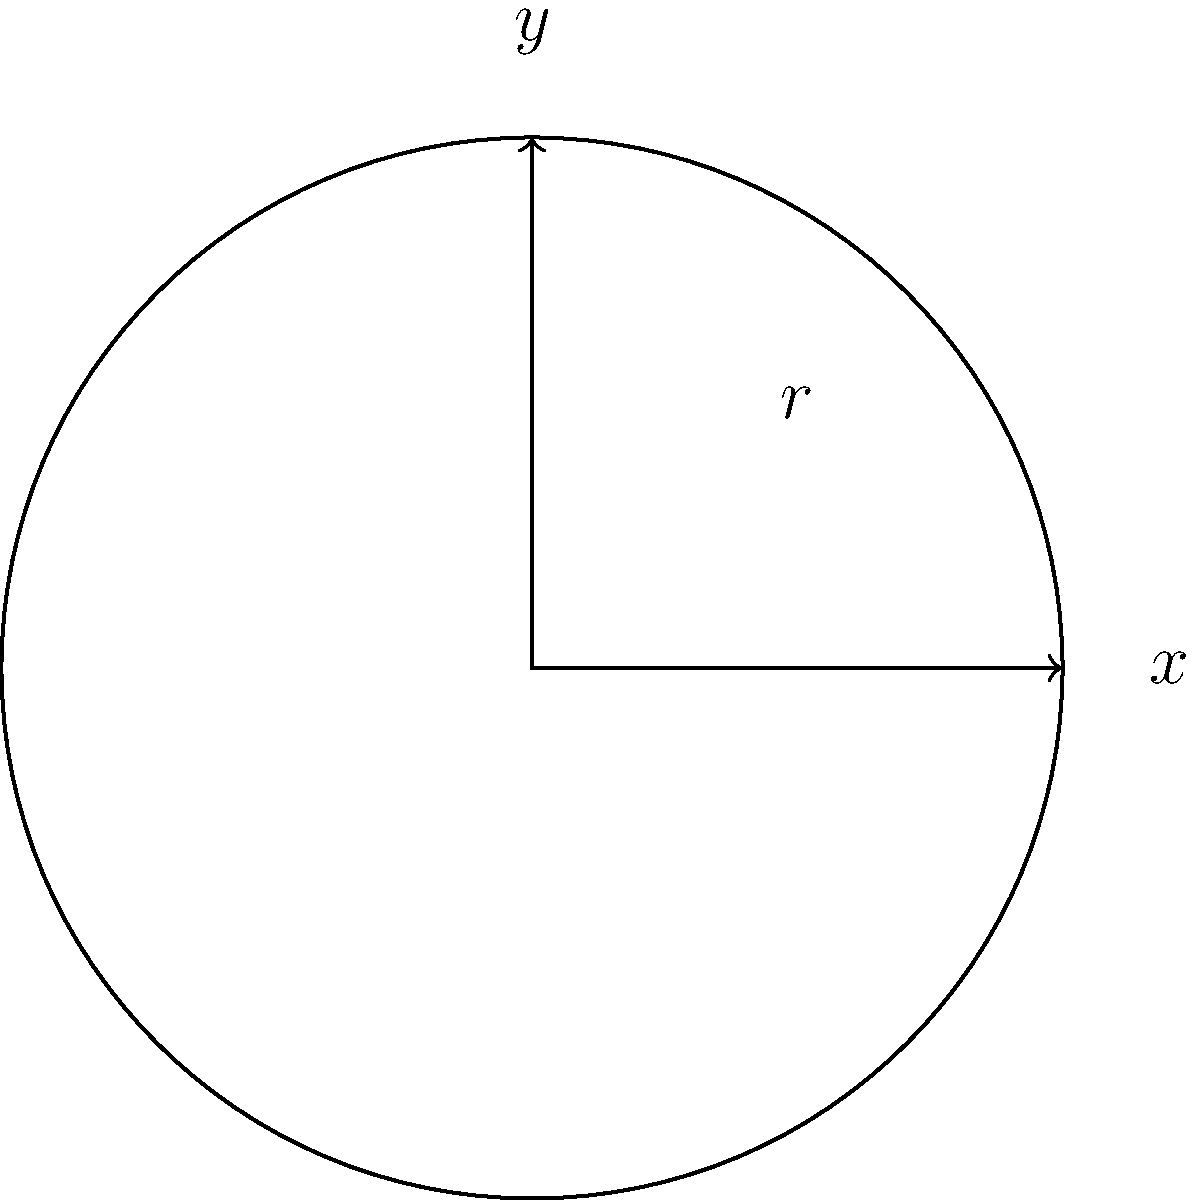As a sports equipment store owner, you're skeptical about new-fangled measuring devices. Using traditional calculus methods, determine the volume of a regulation basketball with a radius of 4.7 inches. Round your answer to the nearest cubic inch. To find the volume of a sphere using calculus, we'll use the method of cylindrical shells:

1) The volume of a sphere is given by the formula:
   $$V = 2\pi \int_0^r y(r^2 - y^2)dy$$
   where $r$ is the radius of the sphere.

2) In this case, $r = 4.7$ inches.

3) Let's substitute this into our formula:
   $$V = 2\pi \int_0^{4.7} y(4.7^2 - y^2)dy$$

4) Simplify the integrand:
   $$V = 2\pi \int_0^{4.7} (22.09y - y^3)dy$$

5) Integrate:
   $$V = 2\pi \left[\frac{22.09y^2}{2} - \frac{y^4}{4}\right]_0^{4.7}$$

6) Evaluate the integral:
   $$V = 2\pi \left(\frac{22.09(4.7)^2}{2} - \frac{(4.7)^4}{4} - 0\right)$$

7) Calculate:
   $$V = 2\pi(243.4423 - 121.7211) = 2\pi(121.7212)$$
   $$V = 764.7698... \text{ cubic inches}$$

8) Rounding to the nearest cubic inch:
   $$V \approx 765 \text{ cubic inches}$$
Answer: 765 cubic inches 